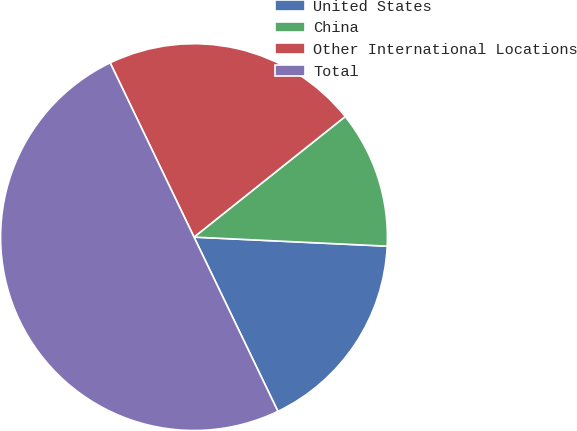<chart> <loc_0><loc_0><loc_500><loc_500><pie_chart><fcel>United States<fcel>China<fcel>Other International Locations<fcel>Total<nl><fcel>17.11%<fcel>11.46%<fcel>21.42%<fcel>50.0%<nl></chart> 